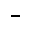Convert formula to latex. <formula><loc_0><loc_0><loc_500><loc_500>^ { - }</formula> 